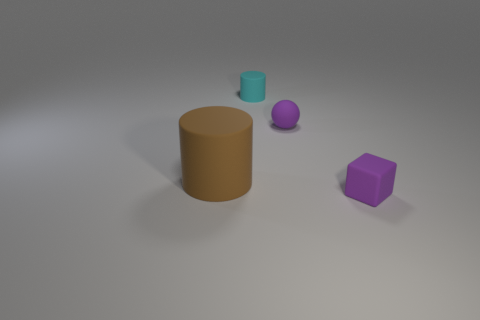What kind of mood or atmosphere does this image evoke? The image exudes a tranquil and introspective mood, attributed to its soft lighting, muted colors, and the simple, uncluttered arrangement of shapes. It could be seen as meditative, encouraging a viewer to reflect on the interplay of form and space. 